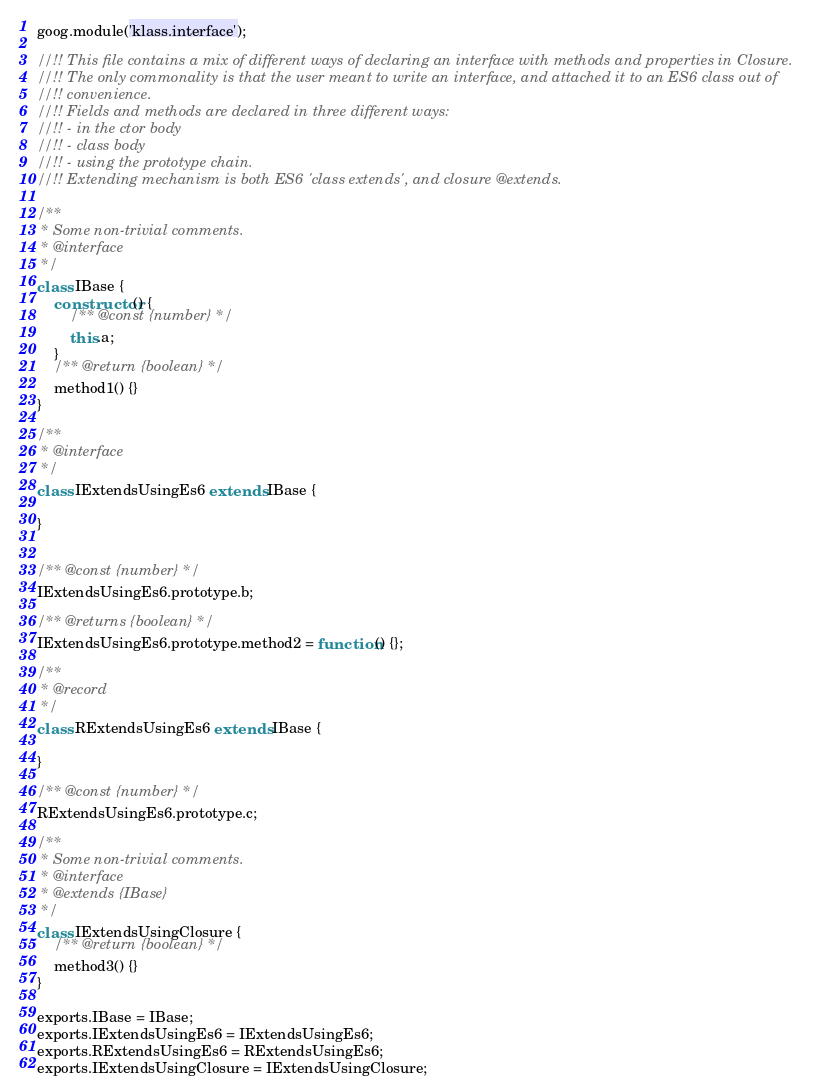Convert code to text. <code><loc_0><loc_0><loc_500><loc_500><_JavaScript_>goog.module('klass.interface');

//!! This file contains a mix of different ways of declaring an interface with methods and properties in Closure.
//!! The only commonality is that the user meant to write an interface, and attached it to an ES6 class out of
//!! convenience.
//!! Fields and methods are declared in three different ways:
//!! - in the ctor body
//!! - class body
//!! - using the prototype chain.
//!! Extending mechanism is both ES6 'class extends', and closure @extends.

/**
 * Some non-trivial comments.
 * @interface
 */
class IBase {
    constructor() {
        /** @const {number} */
        this.a;
    }
    /** @return {boolean} */
    method1() {}
}

/**
 * @interface
 */
class IExtendsUsingEs6 extends IBase {

}


/** @const {number} */
IExtendsUsingEs6.prototype.b;

/** @returns {boolean} */
IExtendsUsingEs6.prototype.method2 = function() {};

/**
 * @record
 */
class RExtendsUsingEs6 extends IBase {

}

/** @const {number} */
RExtendsUsingEs6.prototype.c;

/**
 * Some non-trivial comments.
 * @interface
 * @extends {IBase}
 */
class IExtendsUsingClosure {
    /** @return {boolean} */
    method3() {}
}

exports.IBase = IBase;
exports.IExtendsUsingEs6 = IExtendsUsingEs6;
exports.RExtendsUsingEs6 = RExtendsUsingEs6;
exports.IExtendsUsingClosure = IExtendsUsingClosure;</code> 